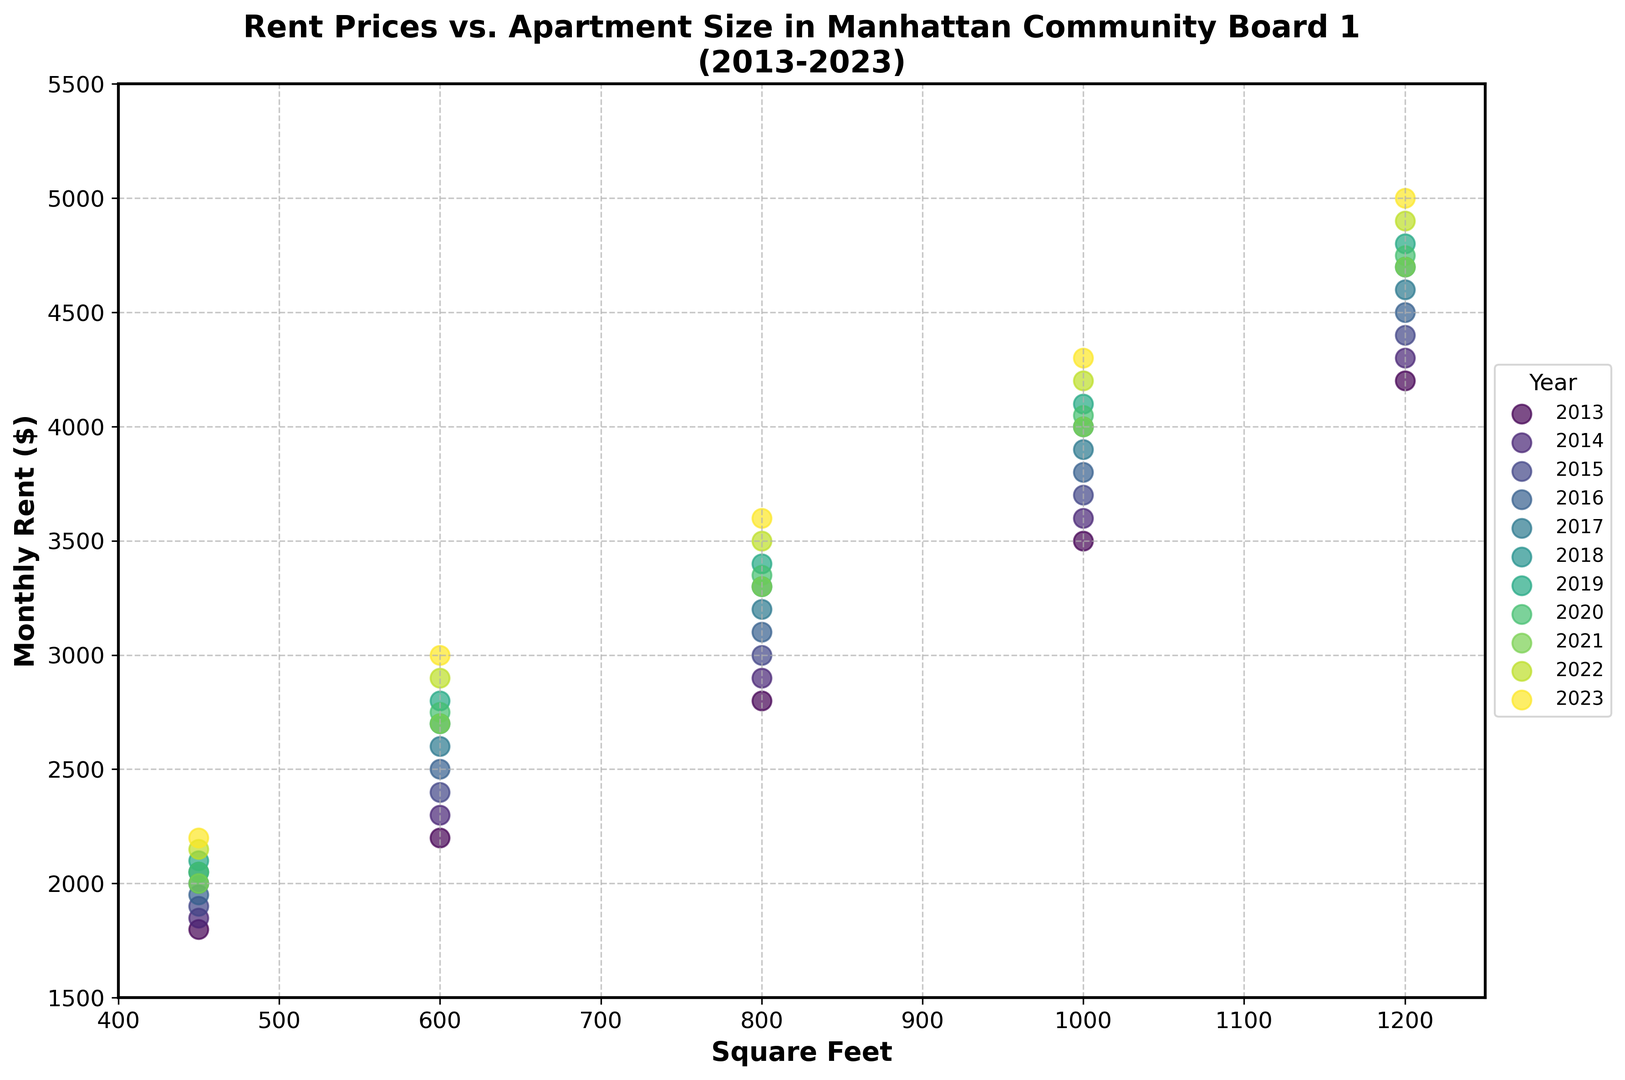what trend do you observe in rent prices as the apartment size increases from 450 to 1200 square feet across all years? As the square footage of apartments increases, the monthly rent also increases. This trend is consistent across all years from 2013 to 2023. Generally, a larger apartment size leads to a higher monthly rent.
Answer: Rent increases with square footage Which year had the highest rent for a 1000 square foot apartment? To determine this, look at the scatter plot points for 1000 sq ft apartments and compare their rent values across all years. The data demonstrates that the highest rent for a 1000 square foot apartment appears in the year 2023.
Answer: 2023 What is the difference in monthly rent for a 800 square foot apartment between 2013 and 2023? First, locate the points for 800 square feet in 2013 and 2023. The rent in 2013 for a 800 sq ft apartment is $2800 and in 2023 it is $3600. The difference is calculated as $3600 - $2800.
Answer: $800 